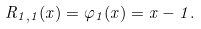Convert formula to latex. <formula><loc_0><loc_0><loc_500><loc_500>R _ { 1 , 1 } ( x ) = \varphi _ { 1 } ( x ) = x - 1 .</formula> 